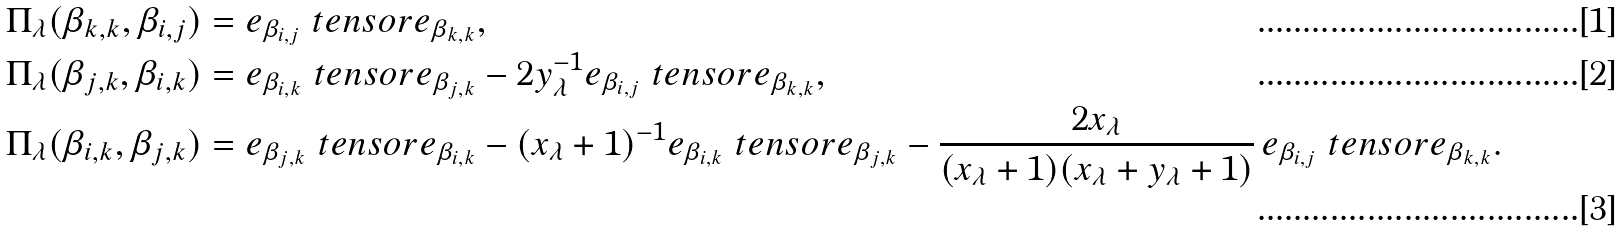<formula> <loc_0><loc_0><loc_500><loc_500>& \Pi _ { \lambda } ( \beta _ { k , k } , \beta _ { i , j } ) = e _ { \beta _ { i , j } } \ t e n s o r e _ { \beta _ { k , k } } , \\ & \Pi _ { \lambda } ( \beta _ { j , k } , \beta _ { i , k } ) = e _ { \beta _ { i , k } } \ t e n s o r e _ { \beta _ { j , k } } - 2 y _ { \lambda } ^ { - 1 } e _ { \beta _ { i , j } } \ t e n s o r e _ { \beta _ { k , k } } , \\ & \Pi _ { \lambda } ( \beta _ { i , k } , \beta _ { j , k } ) = e _ { \beta _ { j , k } } \ t e n s o r e _ { \beta _ { i , k } } - ( x _ { \lambda } + 1 ) ^ { - 1 } e _ { \beta _ { i , k } } \ t e n s o r e _ { \beta _ { j , k } } - \frac { 2 x _ { \lambda } } { ( x _ { \lambda } + 1 ) ( x _ { \lambda } + y _ { \lambda } + 1 ) } \, e _ { \beta _ { i , j } } \ t e n s o r e _ { \beta _ { k , k } } .</formula> 